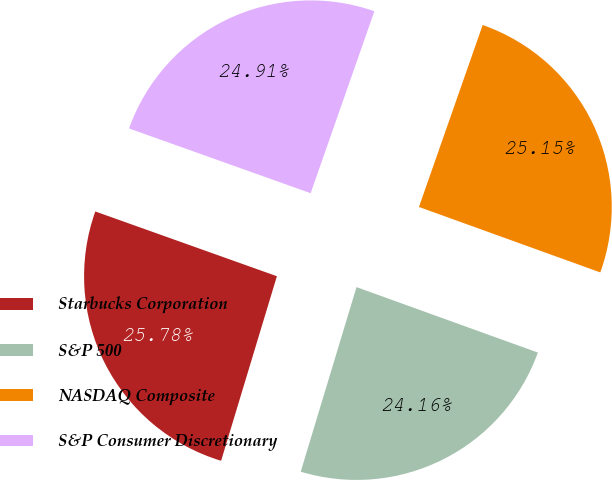<chart> <loc_0><loc_0><loc_500><loc_500><pie_chart><fcel>Starbucks Corporation<fcel>S&P 500<fcel>NASDAQ Composite<fcel>S&P Consumer Discretionary<nl><fcel>25.78%<fcel>24.16%<fcel>25.15%<fcel>24.91%<nl></chart> 